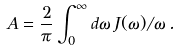Convert formula to latex. <formula><loc_0><loc_0><loc_500><loc_500>A = \frac { 2 } { \pi } \int _ { 0 } ^ { \infty } d \omega \, J ( \omega ) / \omega \, .</formula> 